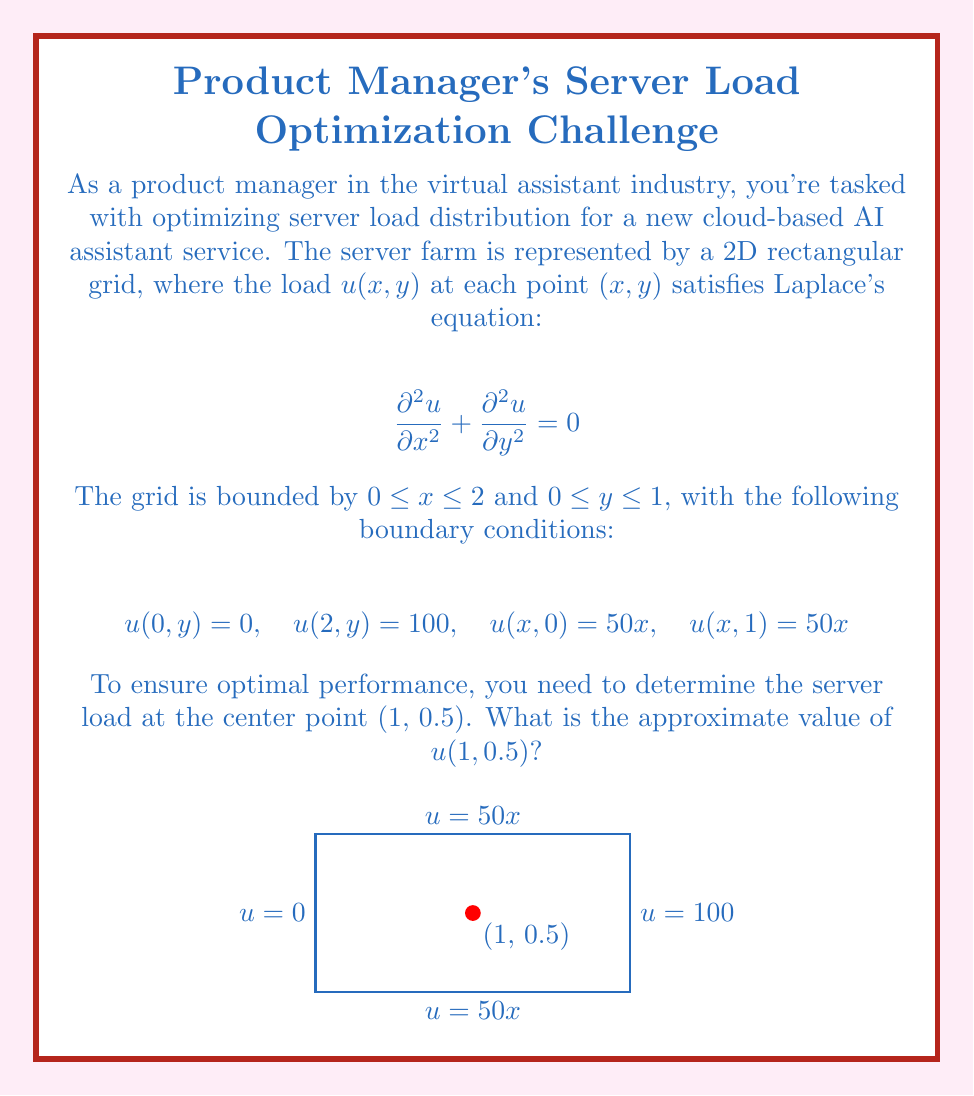Teach me how to tackle this problem. To solve this problem, we'll use the method of separation of variables for Laplace's equation.

1) Assume a solution of the form $u(x,y) = X(x)Y(y)$.

2) Substituting into Laplace's equation:
   $$X''(x)Y(y) + X(x)Y''(y) = 0$$
   $$\frac{X''(x)}{X(x)} = -\frac{Y''(y)}{Y(y)} = \lambda$$

3) This leads to two ODEs:
   $$X''(x) - \lambda X(x) = 0$$
   $$Y''(y) + \lambda Y(y) = 0$$

4) The general solutions are:
   $$X(x) = A\cosh(\sqrt{\lambda}x) + B\sinh(\sqrt{\lambda}x)$$
   $$Y(y) = C\cos(\sqrt{\lambda}y) + D\sin(\sqrt{\lambda}y)$$

5) Applying the boundary conditions $u(0,y) = 0$ and $u(2,y) = 100$:
   $$X(0) = 0 \implies A = 0$$
   $$X(2) = 100 \implies B\sinh(2\sqrt{\lambda}) = 100$$

6) The boundary conditions $u(x,0) = 50x$ and $u(x,1) = 50x$ suggest that $Y(y)$ is constant:
   $$Y(y) = 1$$

7) This means $\lambda = 0$, and our solution becomes:
   $$u(x,y) = Bx$$

8) Applying the boundary condition $u(2,y) = 100$:
   $$100 = 2B \implies B = 50$$

9) Therefore, the solution is:
   $$u(x,y) = 50x$$

10) At the point (1, 0.5):
    $$u(1, 0.5) = 50(1) = 50$$
Answer: 50 